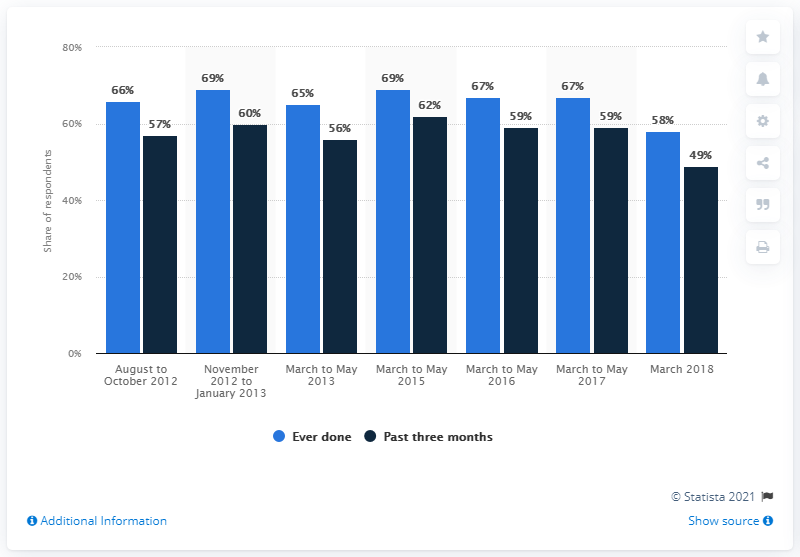Highlight a few significant elements in this photo. The value of the highest dark blue bar is 62. The sum of the highest and lowest values of the light blue bar is 127. 